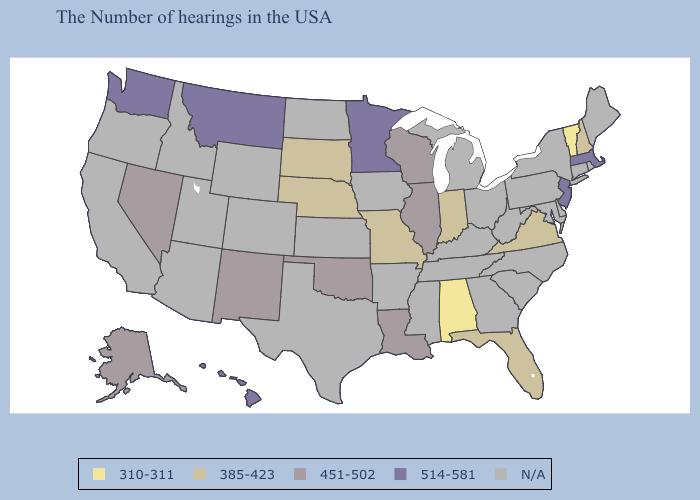What is the value of Kentucky?
Give a very brief answer. N/A. Among the states that border Georgia , does Florida have the highest value?
Answer briefly. Yes. Does Louisiana have the lowest value in the USA?
Keep it brief. No. What is the lowest value in states that border West Virginia?
Write a very short answer. 385-423. Which states have the lowest value in the West?
Short answer required. New Mexico, Nevada, Alaska. Name the states that have a value in the range 514-581?
Be succinct. Massachusetts, New Jersey, Minnesota, Montana, Washington, Hawaii. Name the states that have a value in the range N/A?
Quick response, please. Maine, Rhode Island, Connecticut, New York, Delaware, Maryland, Pennsylvania, North Carolina, South Carolina, West Virginia, Ohio, Georgia, Michigan, Kentucky, Tennessee, Mississippi, Arkansas, Iowa, Kansas, Texas, North Dakota, Wyoming, Colorado, Utah, Arizona, Idaho, California, Oregon. Does the map have missing data?
Short answer required. Yes. Which states have the lowest value in the MidWest?
Give a very brief answer. Indiana, Missouri, Nebraska, South Dakota. What is the highest value in states that border Mississippi?
Concise answer only. 451-502. Name the states that have a value in the range N/A?
Give a very brief answer. Maine, Rhode Island, Connecticut, New York, Delaware, Maryland, Pennsylvania, North Carolina, South Carolina, West Virginia, Ohio, Georgia, Michigan, Kentucky, Tennessee, Mississippi, Arkansas, Iowa, Kansas, Texas, North Dakota, Wyoming, Colorado, Utah, Arizona, Idaho, California, Oregon. What is the lowest value in states that border Alabama?
Concise answer only. 385-423. What is the value of Nebraska?
Concise answer only. 385-423. Among the states that border Illinois , which have the highest value?
Be succinct. Wisconsin. What is the value of Maryland?
Quick response, please. N/A. 